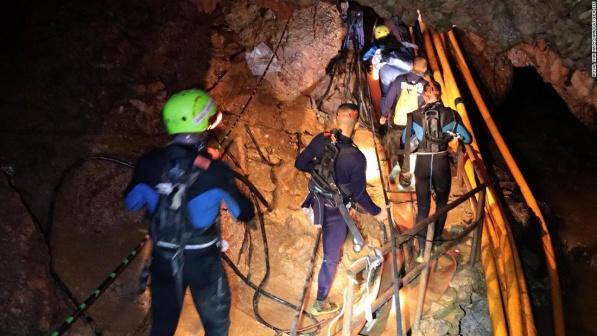Invent a backstory for these adventurers. Who are they, and what has brought them together for this exploration? These five adventurers, known as 'The Caving Cohorts,' are a diverse group of cave enthusiasts with different backgrounds united by their passion for underground exploration. Alex, the group's leader in the blue wetsuit, is a geologist fascinated by subterranean rock formations. Maria, next to him, is a biologist researching cave-dwelling organisms. Ken, in the green helmet, is an engineer developing better illumination systems for caving. Sara and James, the newcomers in orange, are friends from college who joined the group to seek out adrenaline-pumping challenges. Their shared adventures began at a caving workshop, and they've since formed a strong bond as they uncover the wonders and mysteries of the underground world. United by curiosity and a yearning for adventure, The Caving Cohorts' explorations have taken them to some of the most remote and fascinating cave systems around the globe. Their collective expertise in geology, biology, engineering, and sheer enthusiasm has made each expedition a journey of discovery and personal growth. With every new cave, they uncover stories of the past, marvel at the natural sculptures formed over millennia, and face their fears together, emerging not only as better explorers but also as closer friends. 